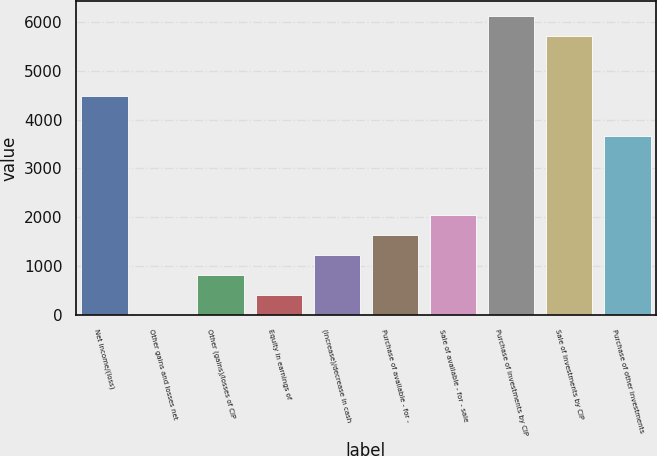<chart> <loc_0><loc_0><loc_500><loc_500><bar_chart><fcel>Net income/(loss)<fcel>Other gains and losses net<fcel>Other (gains)/losses of CIP<fcel>Equity in earnings of<fcel>(Increase)/decrease in cash<fcel>Purchase of available - for -<fcel>Sale of available - for - sale<fcel>Purchase of investments by CIP<fcel>Sale of investments by CIP<fcel>Purchase of other investments<nl><fcel>4488.62<fcel>1.5<fcel>817.34<fcel>409.42<fcel>1225.26<fcel>1633.18<fcel>2041.1<fcel>6120.3<fcel>5712.38<fcel>3672.78<nl></chart> 